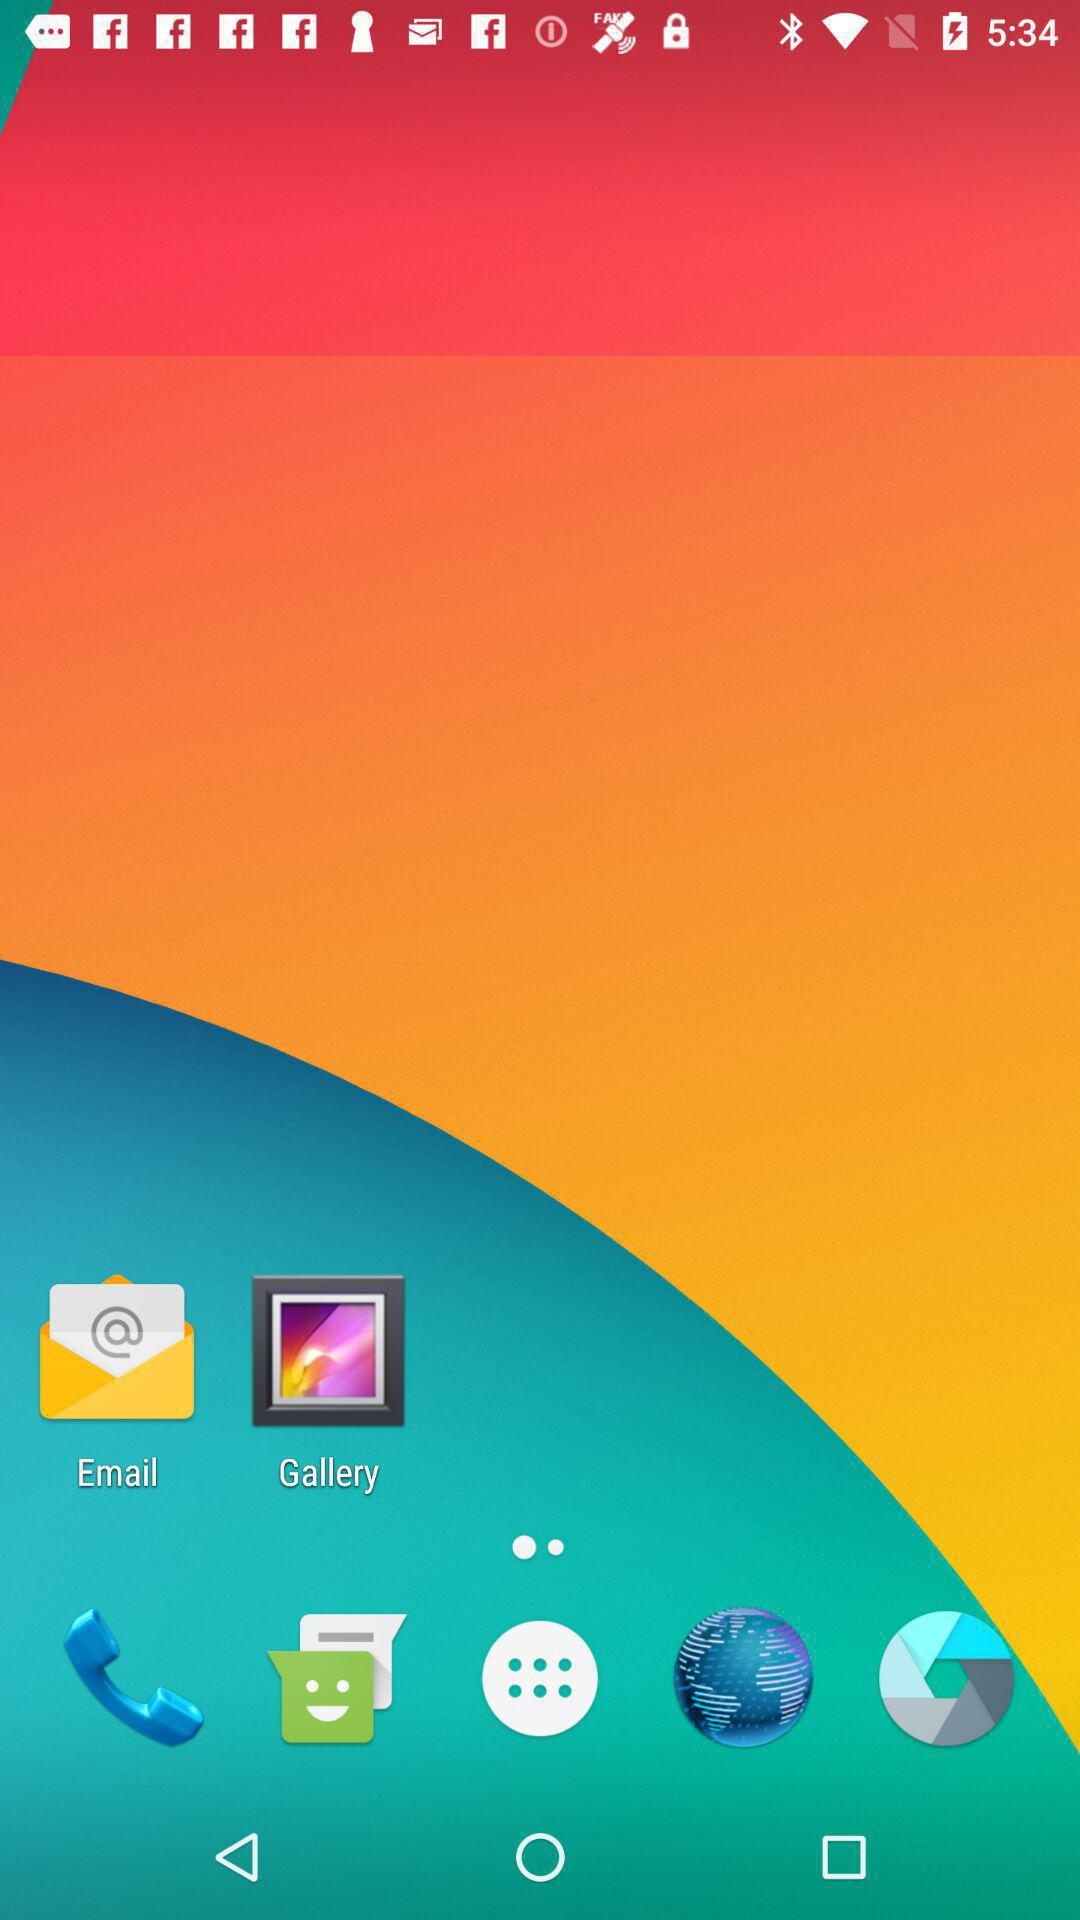What language is selected? The selected language is English. 